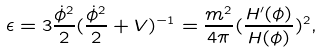Convert formula to latex. <formula><loc_0><loc_0><loc_500><loc_500>\epsilon = 3 \frac { \dot { \phi } ^ { 2 } } { 2 } ( \frac { \dot { \phi } ^ { 2 } } { 2 } + V ) ^ { - 1 } = \frac { m ^ { 2 } } { 4 \pi } ( \frac { H ^ { \prime } ( \phi ) } { H ( \phi ) } ) ^ { 2 } ,</formula> 